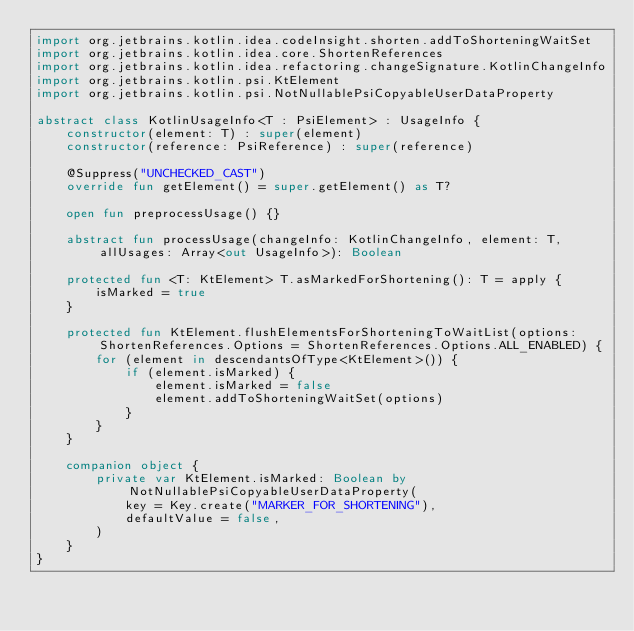Convert code to text. <code><loc_0><loc_0><loc_500><loc_500><_Kotlin_>import org.jetbrains.kotlin.idea.codeInsight.shorten.addToShorteningWaitSet
import org.jetbrains.kotlin.idea.core.ShortenReferences
import org.jetbrains.kotlin.idea.refactoring.changeSignature.KotlinChangeInfo
import org.jetbrains.kotlin.psi.KtElement
import org.jetbrains.kotlin.psi.NotNullablePsiCopyableUserDataProperty

abstract class KotlinUsageInfo<T : PsiElement> : UsageInfo {
    constructor(element: T) : super(element)
    constructor(reference: PsiReference) : super(reference)

    @Suppress("UNCHECKED_CAST")
    override fun getElement() = super.getElement() as T?

    open fun preprocessUsage() {}

    abstract fun processUsage(changeInfo: KotlinChangeInfo, element: T, allUsages: Array<out UsageInfo>): Boolean

    protected fun <T: KtElement> T.asMarkedForShortening(): T = apply {
        isMarked = true
    }

    protected fun KtElement.flushElementsForShorteningToWaitList(options: ShortenReferences.Options = ShortenReferences.Options.ALL_ENABLED) {
        for (element in descendantsOfType<KtElement>()) {
            if (element.isMarked) {
                element.isMarked = false
                element.addToShorteningWaitSet(options)
            }
        }
    }

    companion object {
        private var KtElement.isMarked: Boolean by NotNullablePsiCopyableUserDataProperty(
            key = Key.create("MARKER_FOR_SHORTENING"),
            defaultValue = false,
        )
    }
}
</code> 